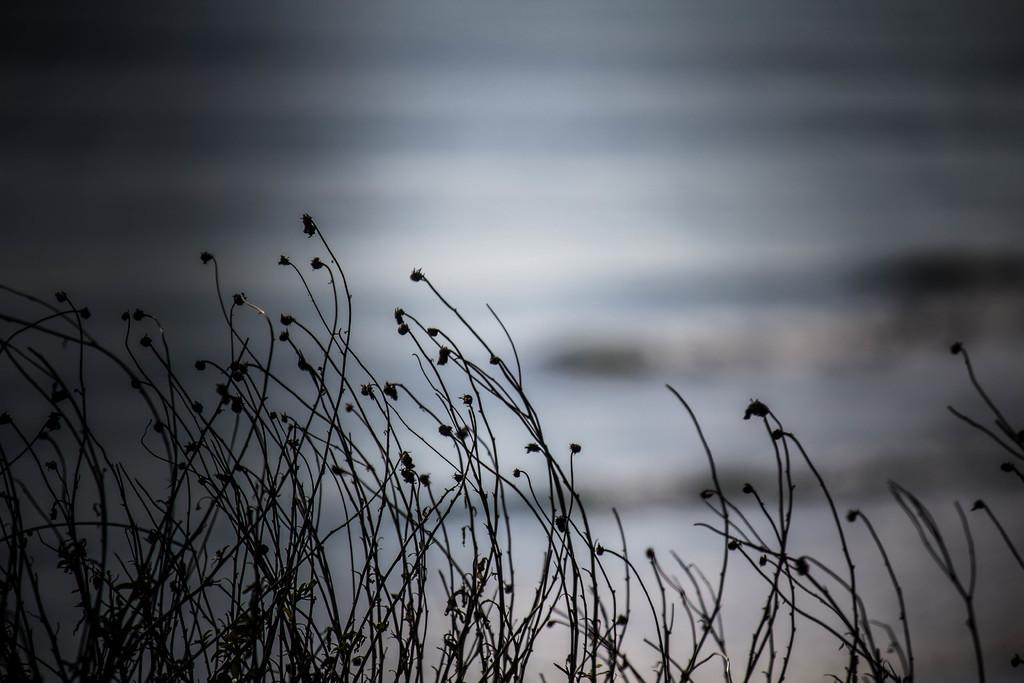What type of living organisms can be seen in the image? Plants can be seen in the image. What type of ball is being used to roll the plants in the image? There is no ball or rolling action present in the image; it simply features plants. 